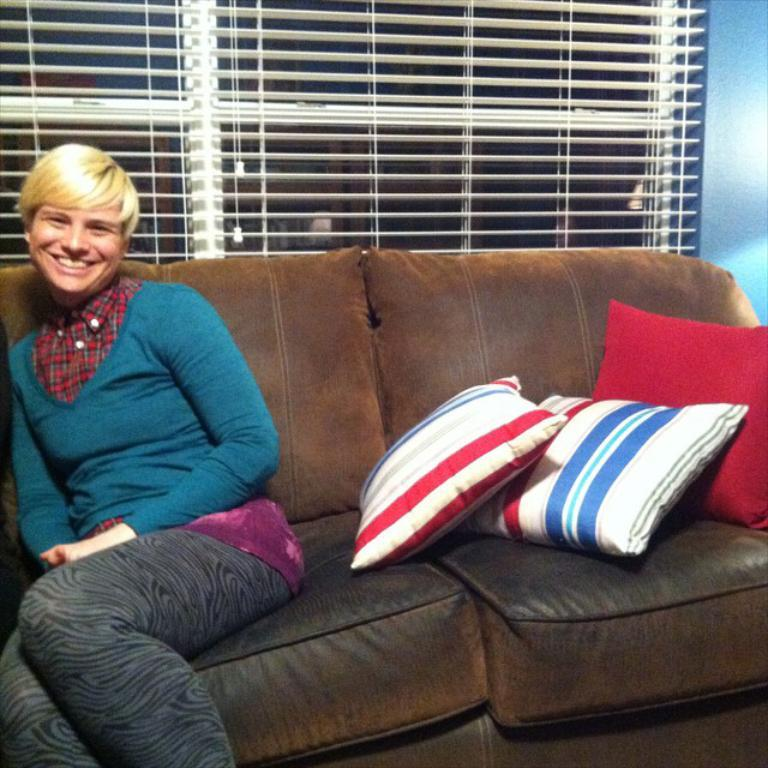What is the woman doing in the image? The woman is sitting on a couch in the image. How many pillows are on the couch with the woman? There are 3 pillows on the couch. What can be seen in the background of the image? There is a window in the background of the image. Is there any window treatment present in the image? Yes, there is a window blind associated with the window. What type of oil can be seen dripping from the woman's hair in the image? There is no oil present in the image, nor is there any indication that the woman's hair is dripping with oil. 